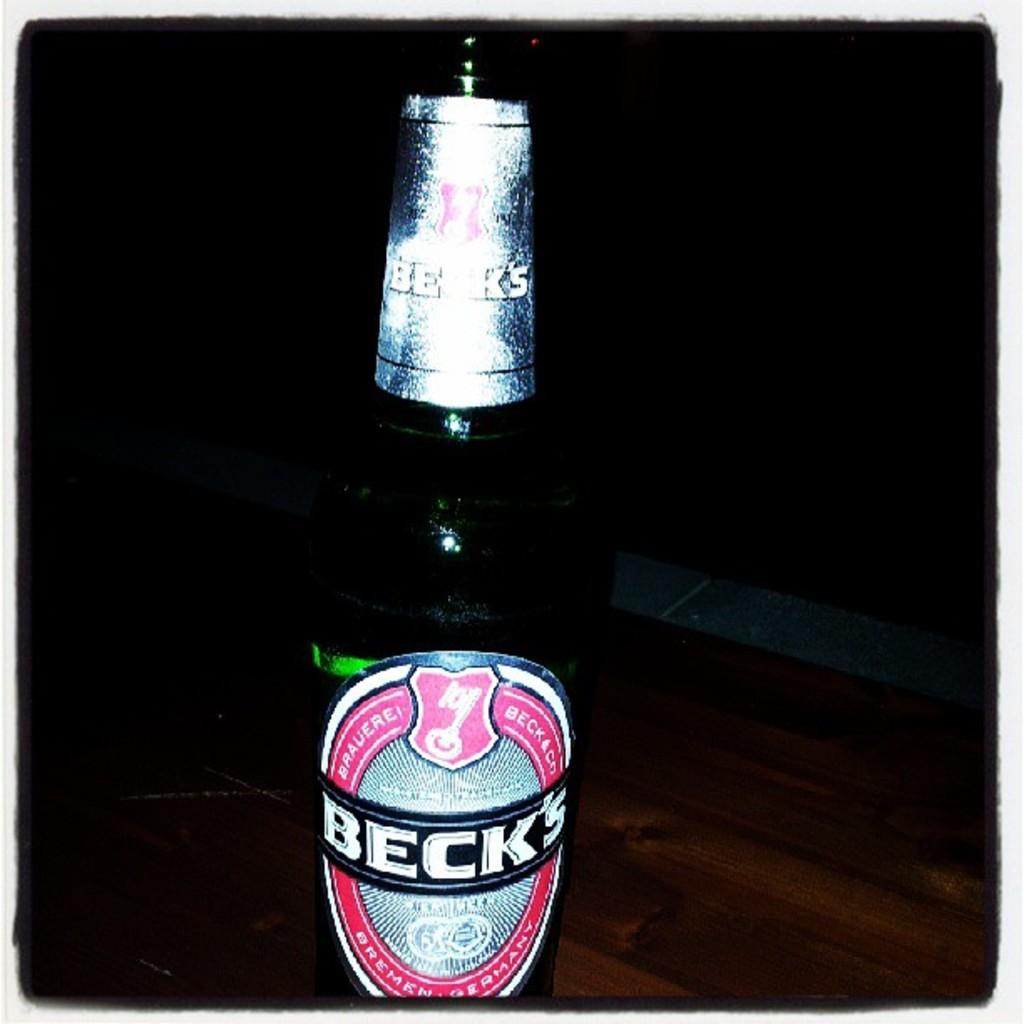<image>
Present a compact description of the photo's key features. a bottle of beck's brauerei beck&co standing by itself on a counter 